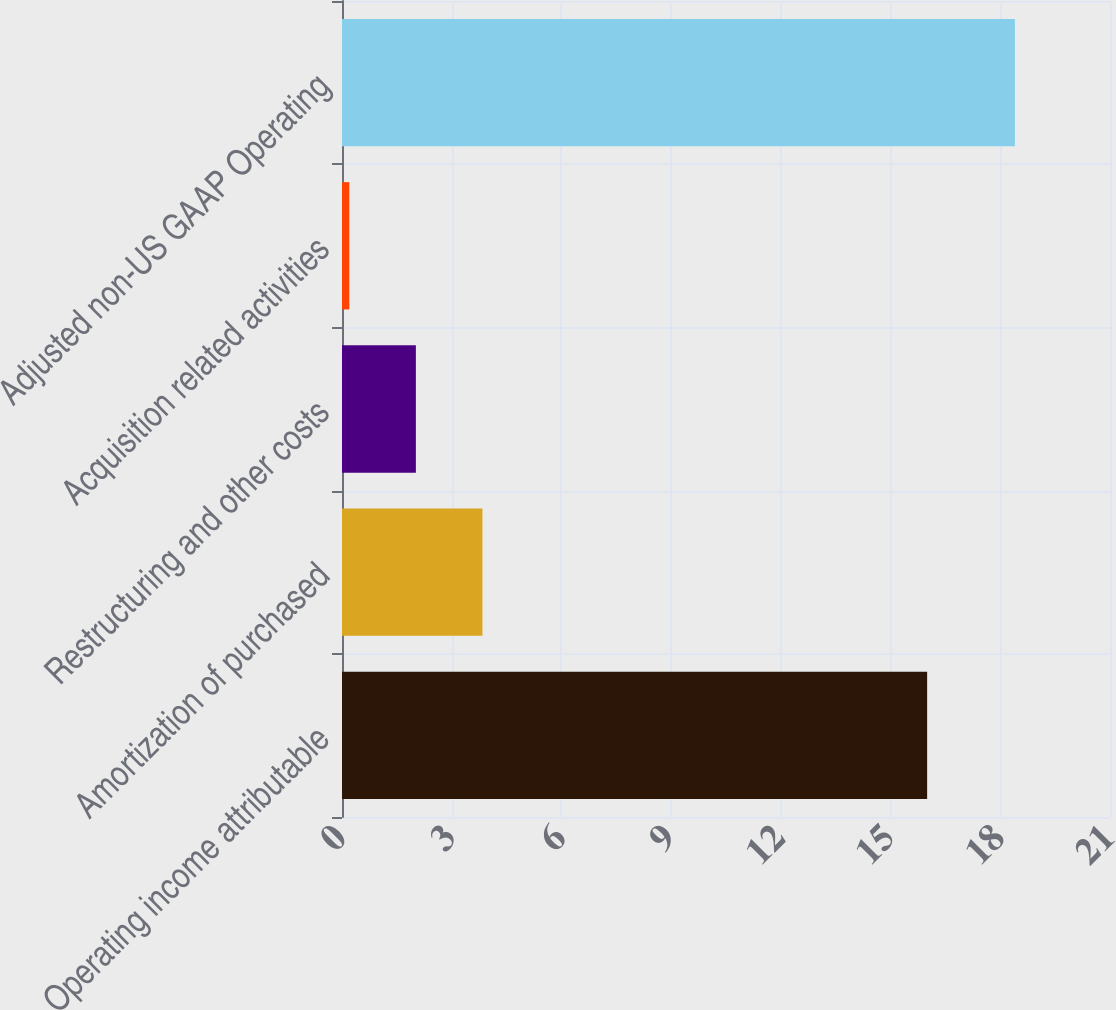<chart> <loc_0><loc_0><loc_500><loc_500><bar_chart><fcel>Operating income attributable<fcel>Amortization of purchased<fcel>Restructuring and other costs<fcel>Acquisition related activities<fcel>Adjusted non-US GAAP Operating<nl><fcel>16<fcel>3.84<fcel>2.02<fcel>0.2<fcel>18.4<nl></chart> 